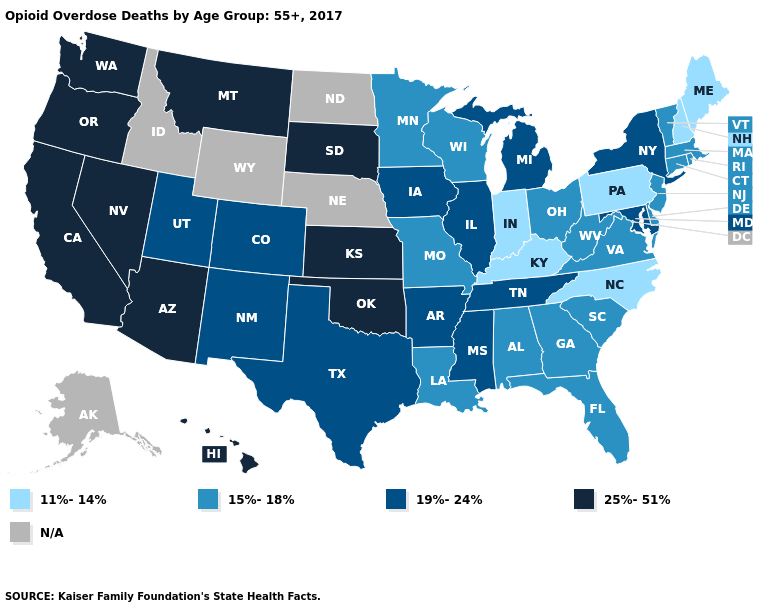Does the first symbol in the legend represent the smallest category?
Short answer required. Yes. Does the map have missing data?
Quick response, please. Yes. Name the states that have a value in the range N/A?
Keep it brief. Alaska, Idaho, Nebraska, North Dakota, Wyoming. Name the states that have a value in the range 19%-24%?
Short answer required. Arkansas, Colorado, Illinois, Iowa, Maryland, Michigan, Mississippi, New Mexico, New York, Tennessee, Texas, Utah. What is the highest value in the USA?
Short answer required. 25%-51%. Among the states that border Arizona , which have the highest value?
Quick response, please. California, Nevada. Name the states that have a value in the range 19%-24%?
Answer briefly. Arkansas, Colorado, Illinois, Iowa, Maryland, Michigan, Mississippi, New Mexico, New York, Tennessee, Texas, Utah. Name the states that have a value in the range 19%-24%?
Give a very brief answer. Arkansas, Colorado, Illinois, Iowa, Maryland, Michigan, Mississippi, New Mexico, New York, Tennessee, Texas, Utah. Among the states that border Kansas , does Missouri have the lowest value?
Answer briefly. Yes. What is the value of Idaho?
Write a very short answer. N/A. Does the first symbol in the legend represent the smallest category?
Give a very brief answer. Yes. Does the first symbol in the legend represent the smallest category?
Give a very brief answer. Yes. Among the states that border Nevada , which have the lowest value?
Quick response, please. Utah. Which states have the highest value in the USA?
Be succinct. Arizona, California, Hawaii, Kansas, Montana, Nevada, Oklahoma, Oregon, South Dakota, Washington. 